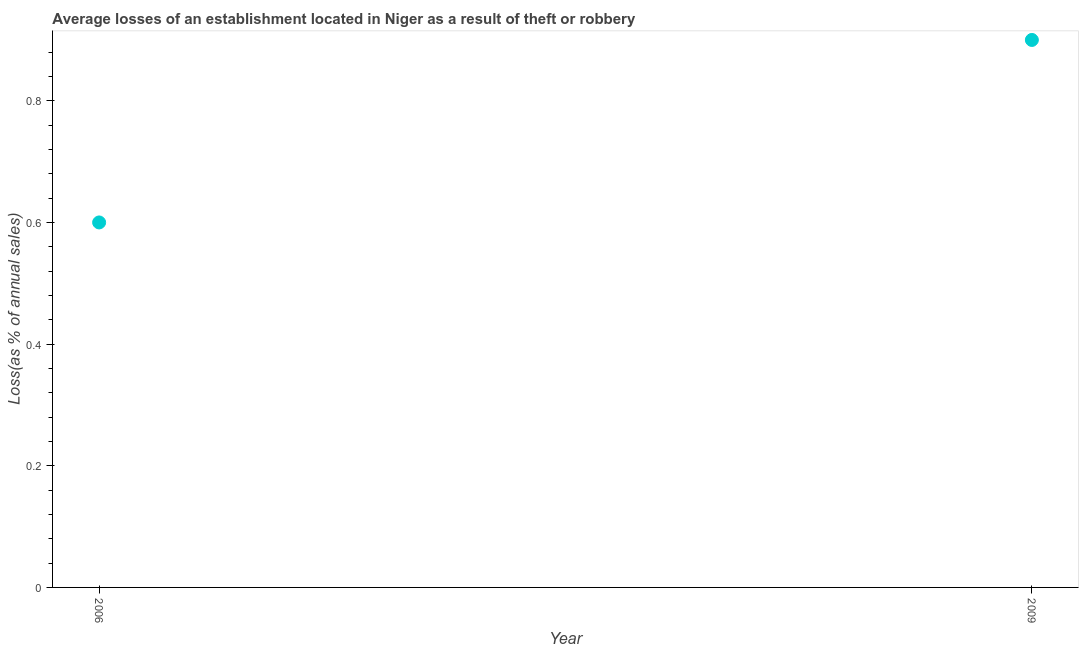What is the losses due to theft in 2006?
Offer a very short reply. 0.6. What is the difference between the losses due to theft in 2006 and 2009?
Your answer should be very brief. -0.3. What is the average losses due to theft per year?
Offer a very short reply. 0.75. What is the ratio of the losses due to theft in 2006 to that in 2009?
Provide a short and direct response. 0.67. Is the losses due to theft in 2006 less than that in 2009?
Make the answer very short. Yes. Does the losses due to theft monotonically increase over the years?
Make the answer very short. Yes. What is the difference between two consecutive major ticks on the Y-axis?
Your answer should be compact. 0.2. What is the title of the graph?
Offer a terse response. Average losses of an establishment located in Niger as a result of theft or robbery. What is the label or title of the Y-axis?
Give a very brief answer. Loss(as % of annual sales). What is the Loss(as % of annual sales) in 2009?
Give a very brief answer. 0.9. What is the difference between the Loss(as % of annual sales) in 2006 and 2009?
Offer a terse response. -0.3. What is the ratio of the Loss(as % of annual sales) in 2006 to that in 2009?
Provide a short and direct response. 0.67. 